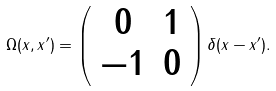<formula> <loc_0><loc_0><loc_500><loc_500>\Omega ( x , x ^ { \prime } ) = \left ( \begin{array} { c c } 0 & 1 \\ - 1 & 0 \end{array} \right ) \delta ( x - x ^ { \prime } ) .</formula> 